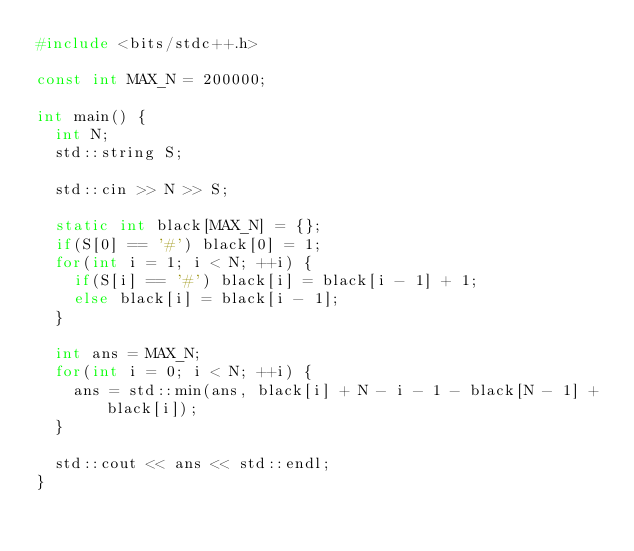<code> <loc_0><loc_0><loc_500><loc_500><_C++_>#include <bits/stdc++.h>

const int MAX_N = 200000;

int main() {
	int N;
	std::string S;

	std::cin >> N >> S;

	static int black[MAX_N] = {};
	if(S[0] == '#') black[0] = 1;
	for(int i = 1; i < N; ++i) {
		if(S[i] == '#') black[i] = black[i - 1] + 1;
		else black[i] = black[i - 1];
	}

	int ans = MAX_N;
	for(int i = 0; i < N; ++i) {
		ans = std::min(ans, black[i] + N - i - 1 - black[N - 1] + black[i]);
	}

	std::cout << ans << std::endl;
}
</code> 